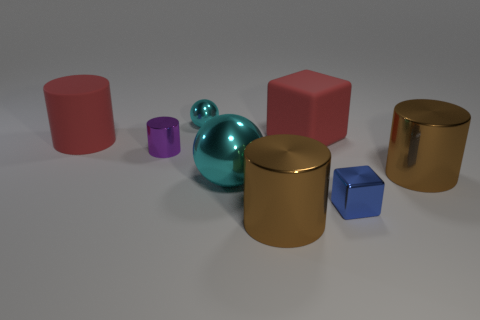Subtract all green cubes. How many brown cylinders are left? 2 Subtract all red cylinders. How many cylinders are left? 3 Subtract all purple cylinders. How many cylinders are left? 3 Add 1 large purple metallic cylinders. How many objects exist? 9 Subtract all gray cylinders. Subtract all cyan cubes. How many cylinders are left? 4 Add 1 cylinders. How many cylinders are left? 5 Add 4 small spheres. How many small spheres exist? 5 Subtract 0 purple balls. How many objects are left? 8 Subtract all cubes. How many objects are left? 6 Subtract all blue shiny cylinders. Subtract all tiny blocks. How many objects are left? 7 